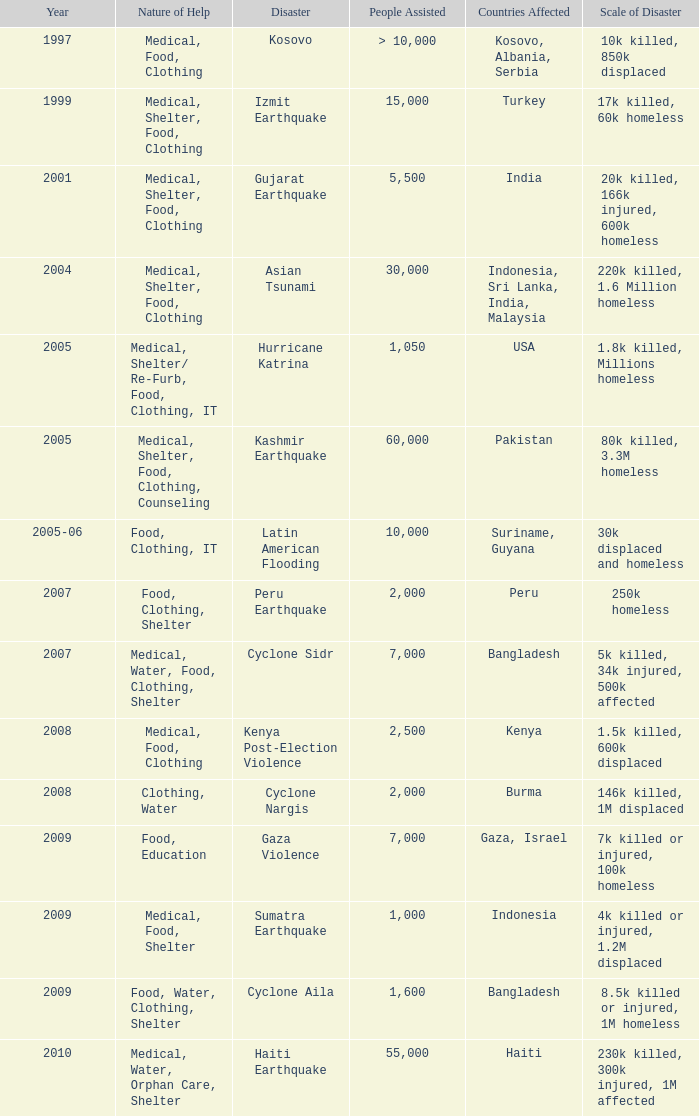What is the scale of disaster for the USA? 1.8k killed, Millions homeless. 